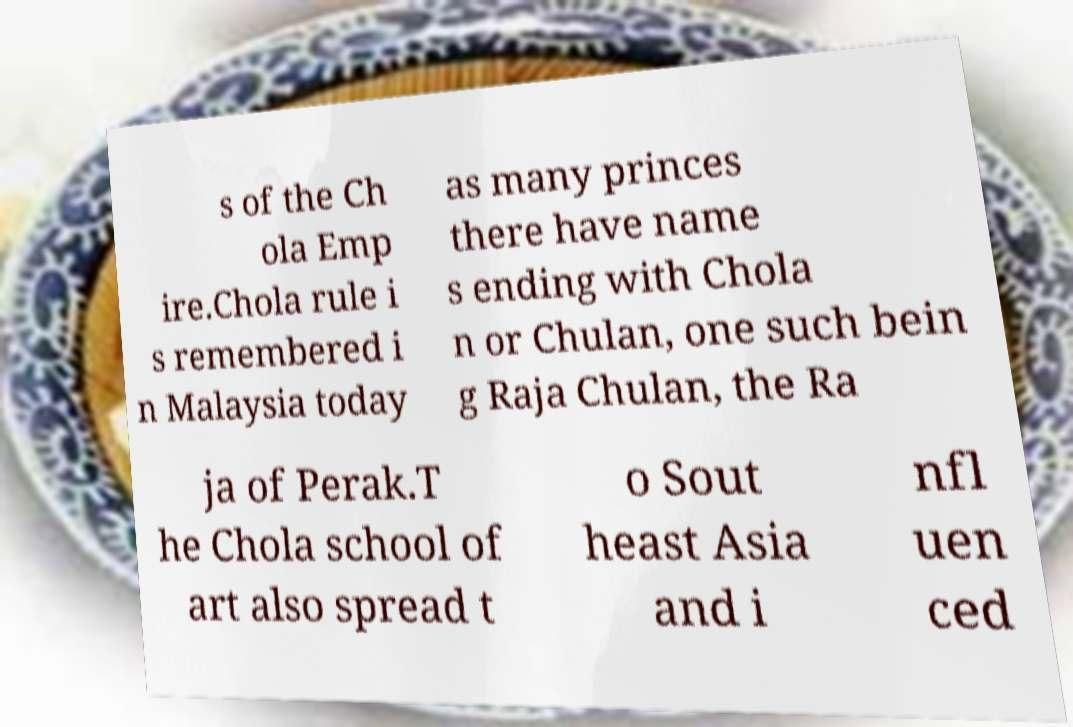Please read and relay the text visible in this image. What does it say? s of the Ch ola Emp ire.Chola rule i s remembered i n Malaysia today as many princes there have name s ending with Chola n or Chulan, one such bein g Raja Chulan, the Ra ja of Perak.T he Chola school of art also spread t o Sout heast Asia and i nfl uen ced 